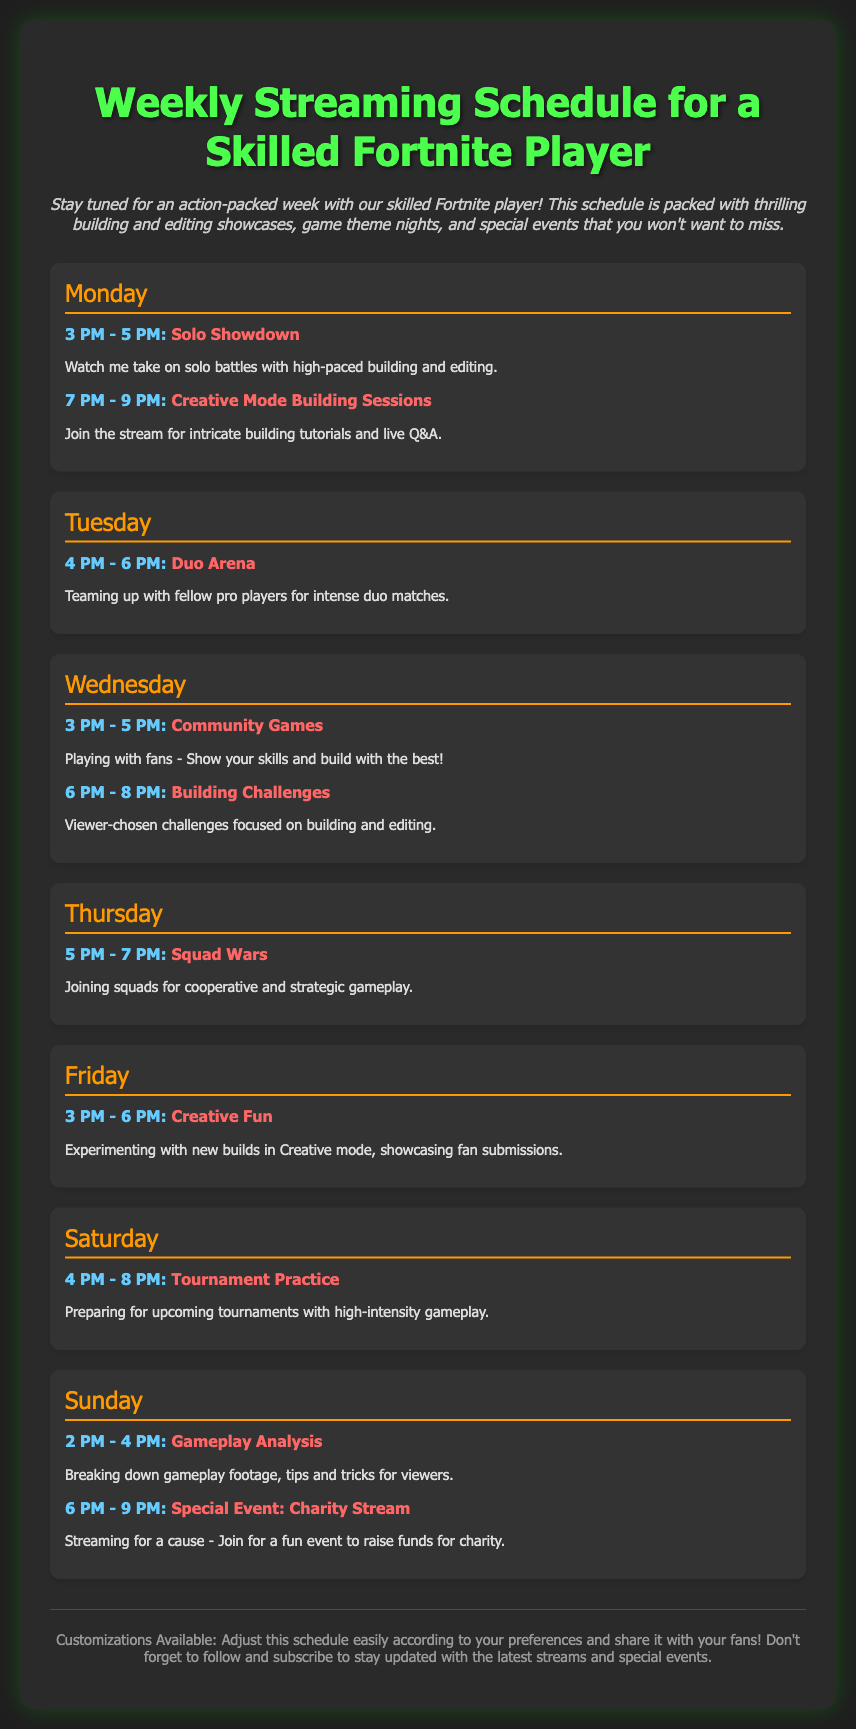What day does the Charity Stream take place? The Charity Stream is listed under Sunday in the schedule.
Answer: Sunday What is the first activity scheduled on Monday? The first activity on Monday is Solo Showdown.
Answer: Solo Showdown How many time slots are there on Wednesday? Wednesday has two time slots in the schedule.
Answer: Two What is the theme of the stream on Friday? The stream on Friday is themed as Creative Fun.
Answer: Creative Fun What time does the gameplay analysis start on Sunday? The gameplay analysis session starts at 2 PM on Sunday.
Answer: 2 PM What description is provided for the Building Challenges? The Building Challenges involve viewer-chosen challenges focused on building and editing.
Answer: Viewer-chosen challenges focused on building and editing Which day of the week has Squad Wars? Squad Wars is scheduled for Thursday.
Answer: Thursday What is indicated to join the stream on Tuesday? The description for Tuesday indicates teaming up with fellow pro players for intense duo matches.
Answer: Teaming up with fellow pro players How long is the streaming session on Saturday? The streaming session on Saturday lasts four hours.
Answer: Four hours 